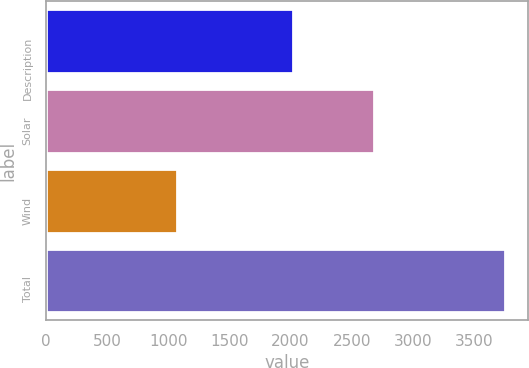Convert chart to OTSL. <chart><loc_0><loc_0><loc_500><loc_500><bar_chart><fcel>Description<fcel>Solar<fcel>Wind<fcel>Total<nl><fcel>2018<fcel>2680<fcel>1074<fcel>3754<nl></chart> 